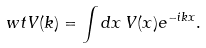<formula> <loc_0><loc_0><loc_500><loc_500>\ w t V ( k ) = \int d x \, V ( x ) e ^ { - i k x } .</formula> 